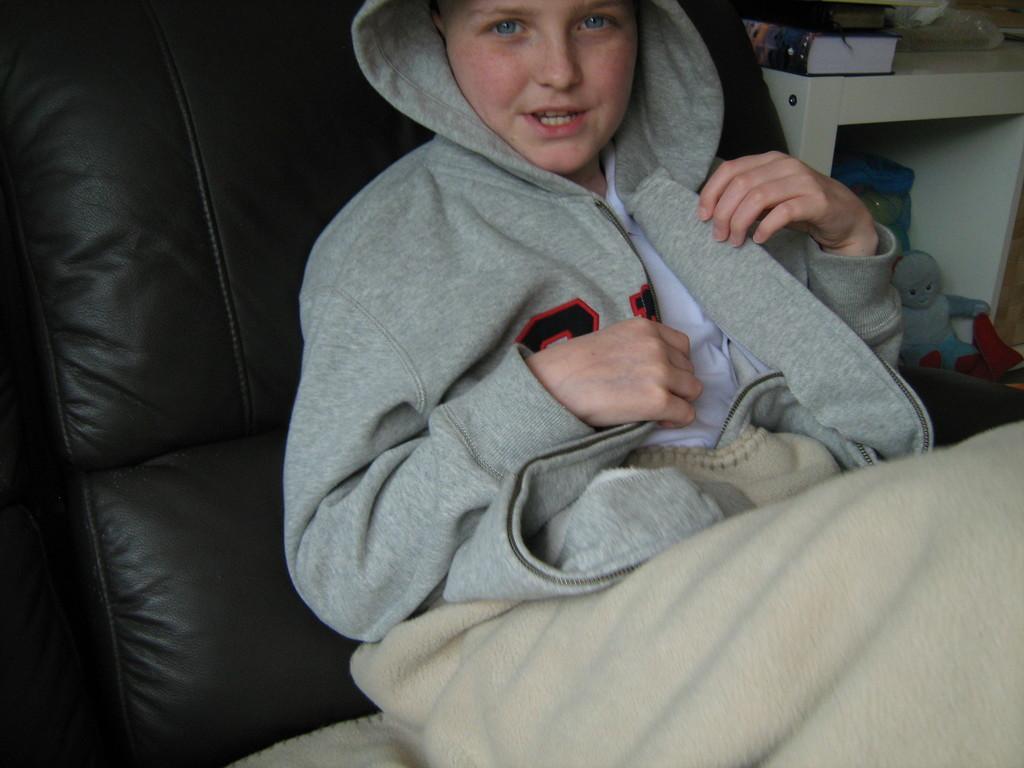Please provide a concise description of this image. in this image there is a person sitting on the couch which is black in colour. On the right side there is a shelf and on the shelf there is a book and there are toys under the shelf and on the person there is a blanket. 